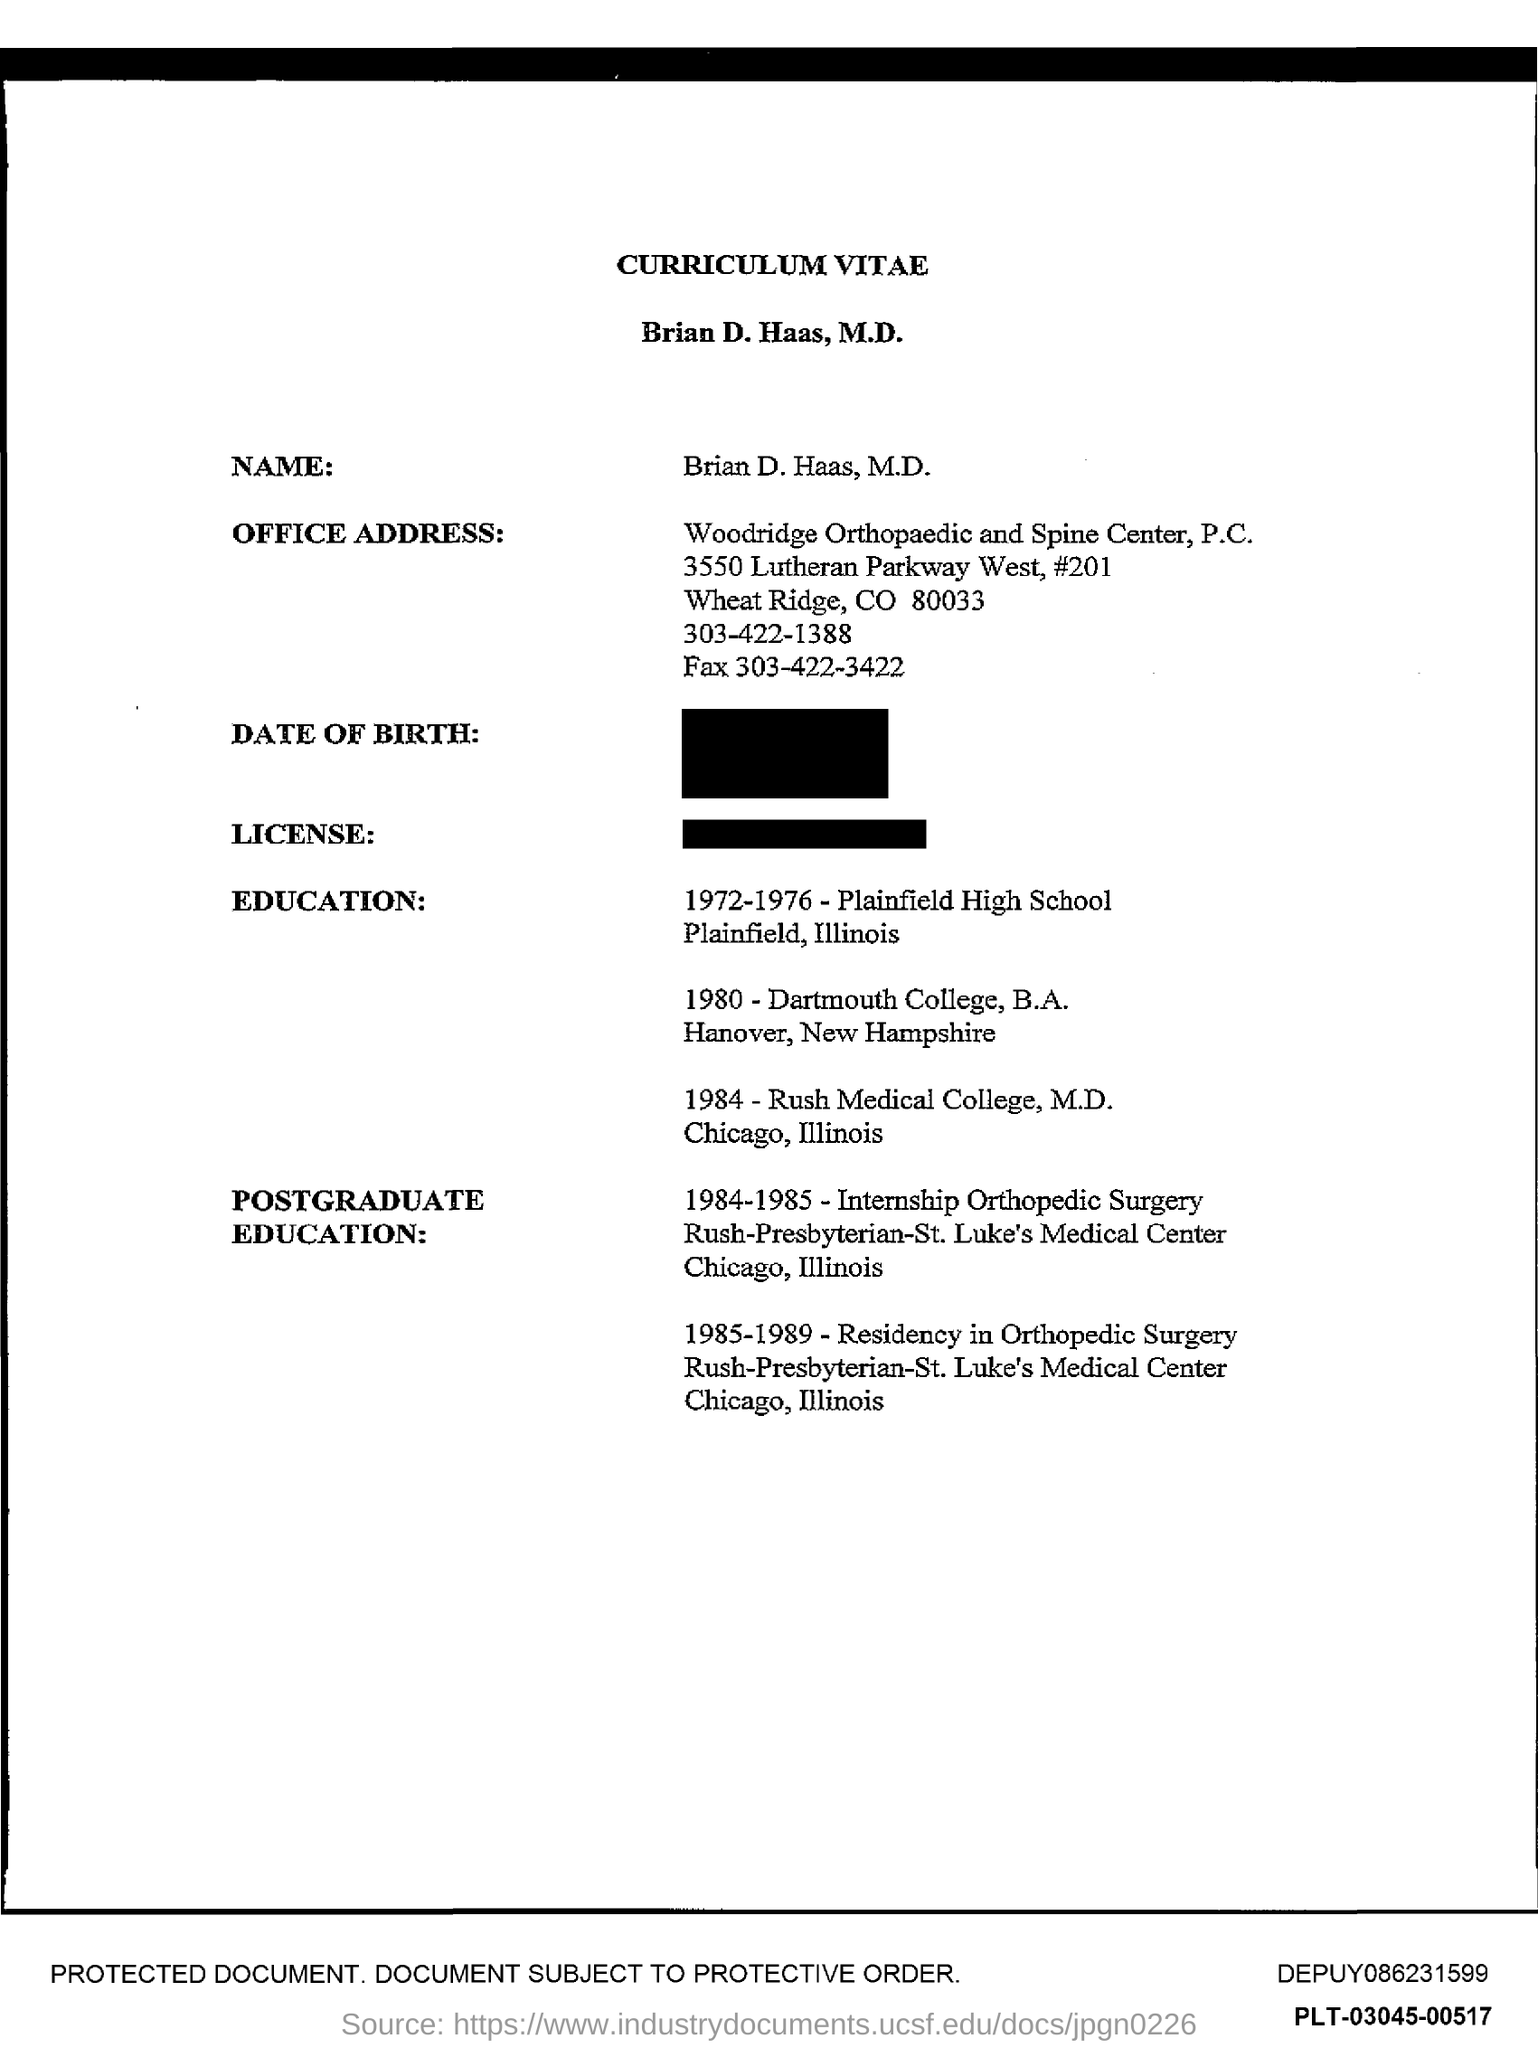What is the "Fax" number given in "OFFICE ADDRESS"?
Keep it short and to the point. 303-422-3422. From which college has he taken "B.A"?
Ensure brevity in your answer.  Dartmouth College. Which year did he study in "Rush Medical College"?
Ensure brevity in your answer.  1984. Brian D. Haas has done "Residency in Orthopedic Surgery" in which year?
Offer a very short reply. 1985-1989. Which "Medical College" has Brian D. Haas done his M.D?
Give a very brief answer. Rush Medical College. Where is "Plainfield High School" located?
Your answer should be compact. Plainfield,Illinois. 